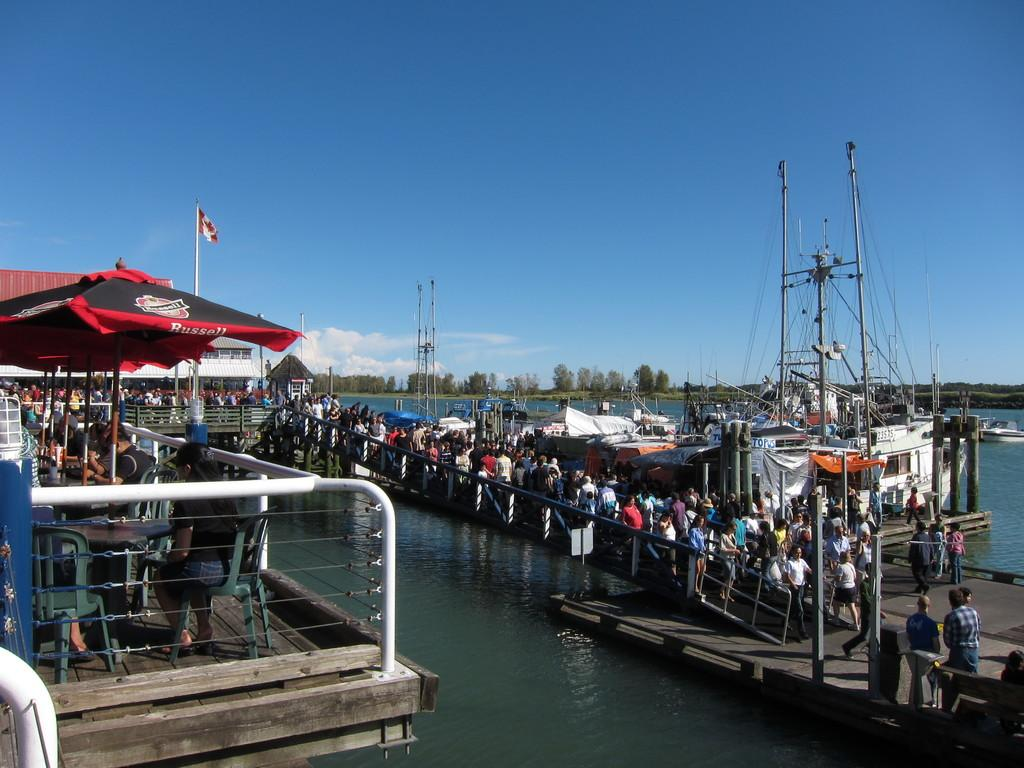How many people are in the image? There are persons in the image, but the exact number is not specified. What type of structure can be seen in the image? There is a bridgewater in the image. What mode of transportation is present in the image? There are ships in the image. What type of furniture is in the image? There are chairs in the image. What type of temporary shelter is in the image? There are tents in the image. What type of permanent structures are in the image? There are buildings in the image. What type of natural vegetation is in the image? There are trees in the image. What part of the natural environment is visible in the image? The sky is visible in the image. What type of atmospheric phenomenon is visible in the sky? There are clouds in the image. What type of instrument is being played by the hen in the image? There is no hen or instrument present in the image. Can you describe the shape and color of the cloud in the image? The provided facts do not specify the shape or color of the cloud in the image. 